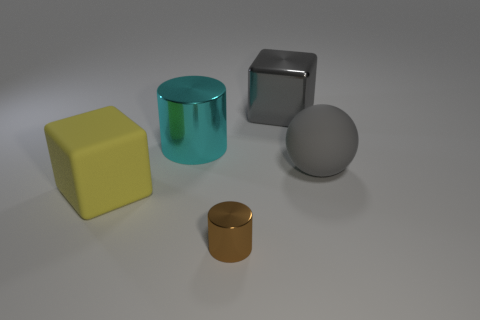The big cube that is in front of the large matte sphere right of the cyan object is what color?
Your answer should be compact. Yellow. There is a large object that is the same material as the gray sphere; what is its color?
Make the answer very short. Yellow. How many spheres have the same color as the large metallic cylinder?
Offer a terse response. 0. What number of objects are big gray spheres or matte cylinders?
Ensure brevity in your answer.  1. There is a gray object that is the same size as the gray matte sphere; what is its shape?
Ensure brevity in your answer.  Cube. What number of cylinders are behind the yellow matte object and in front of the big yellow matte cube?
Keep it short and to the point. 0. There is a gray block that is left of the rubber ball; what is it made of?
Keep it short and to the point. Metal. The brown cylinder that is made of the same material as the cyan cylinder is what size?
Ensure brevity in your answer.  Small. There is a cube that is in front of the sphere; does it have the same size as the gray thing that is in front of the large cyan thing?
Your answer should be very brief. Yes. There is another block that is the same size as the yellow matte block; what material is it?
Offer a terse response. Metal. 